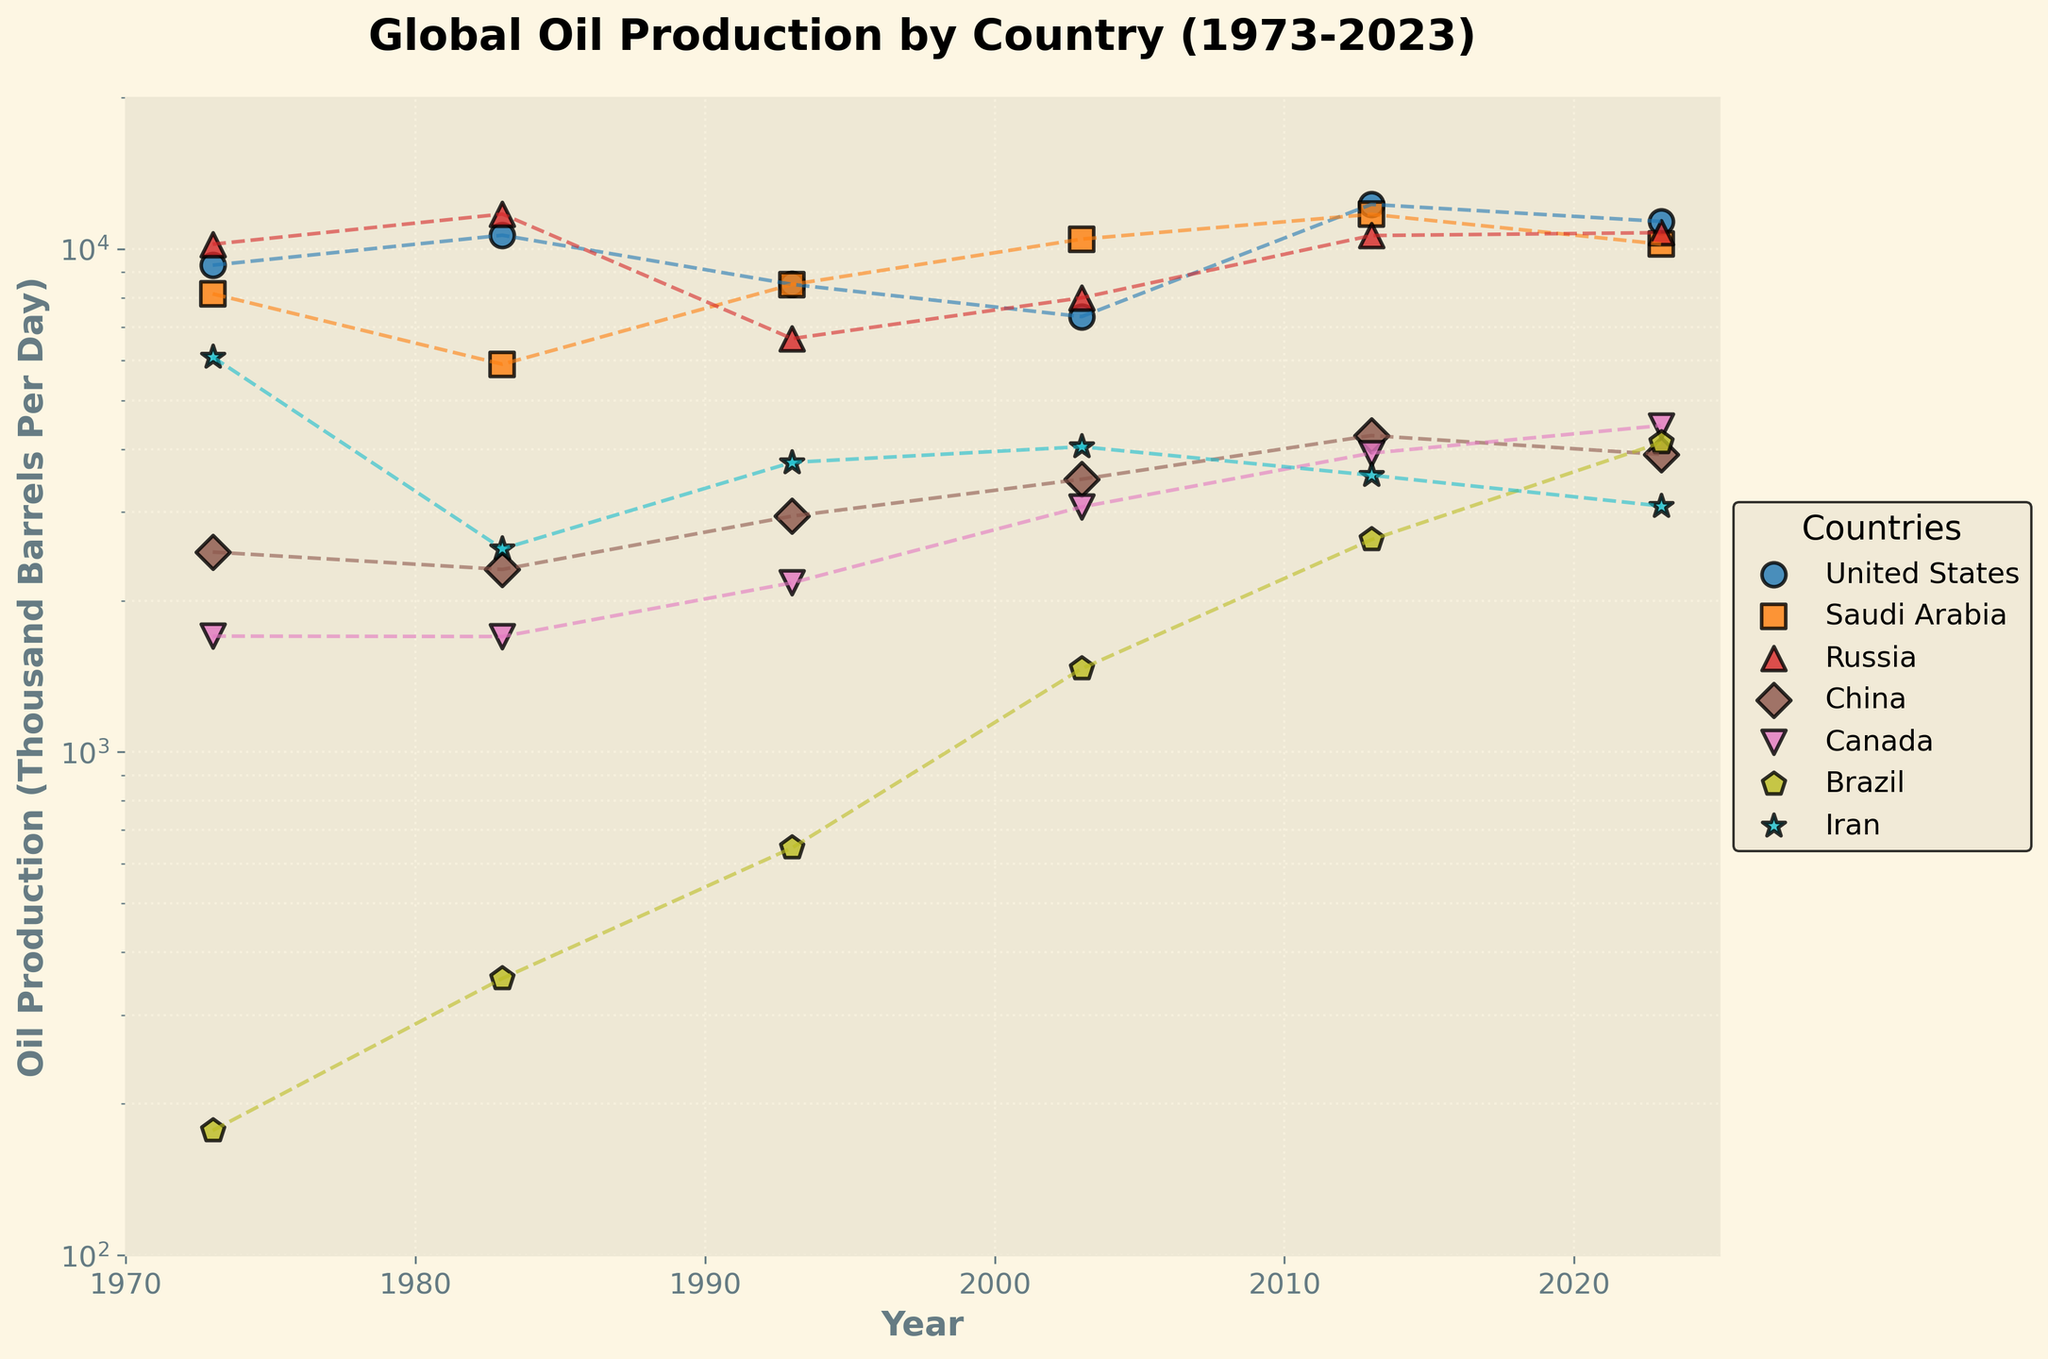What is the title of the figure? The title of the figure is centered at the top and is written in bold.
Answer: Global Oil Production by Country (1973-2023) Which country had the highest oil production in 2023? By looking at the scatter plot for the year 2023, the highest point falls under the United States.
Answer: United States What is the y-axis scale used in the plot? The y-axis scale is labeled and plotted using a logarithmic scale, as indicated by the gaps between the numbers and the axis label stating "log."
Answer: Logarithmic scale Which country experienced the most significant drop in oil production from 2013 to 2023? By comparing the oil production values of each country between 2013 and 2023, Iran's oil production seems to decrease the most.
Answer: Iran Which country had an oil production of around 10,000 thousand barrels per day in 1993? Examining the data points for 1993, the point close to 10,000 thousand barrels per day is Russia.
Answer: Russia Which two countries show an increasing trend in oil production from 1973 to 2023? By examining the connecting lines' slopes from 1973 to 2023, the United States and Brazil display a consistent upward trend.
Answer: United States, Brazil By how many thousand barrels per day did Saudi Arabia’s oil production change from 1983 to 1993? Saudi Arabia's oil production increased from 5,900 thousand barrels per day in 1983 to 8,500 thousand barrels per day in 1993. The difference is computed as 8,500 - 5,900 = 2,600.
Answer: 2,600 Which country exhibited the least variation in oil production over the years? Variability can be observed through the magnitude of changes between data points. China’s values are relatively stable and less varied compared to other countries.
Answer: China Which country’s oil production peaked in the 1980s but subsequently showed an overall decline? Referring to the scatter plot line trends, Iran’s oil production appears to peak in 1983 and shows an overall decline afterward.
Answer: Iran 